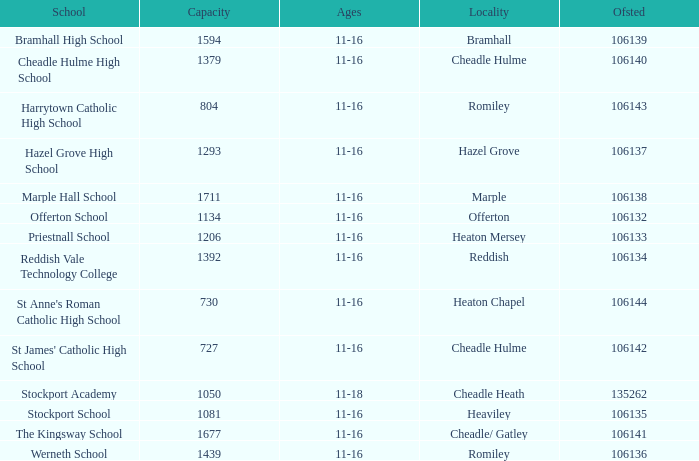Which School has Ages of 11-16, and an Ofsted smaller than 106142, and a Capacity of 1206? Priestnall School. 